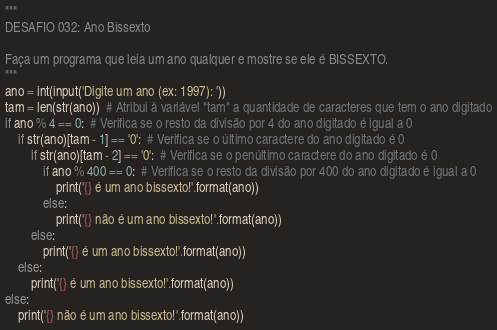<code> <loc_0><loc_0><loc_500><loc_500><_Python_>"""
DESAFIO 032: Ano Bissexto

Faça um programa que leia um ano qualquer e mostre se ele é BISSEXTO.
"""
ano = int(input('Digite um ano (ex: 1997): '))
tam = len(str(ano))  # Atribui à variável "tam" a quantidade de caracteres que tem o ano digitado
if ano % 4 == 0:  # Verifica se o resto da divisão por 4 do ano digitado é igual a 0
    if str(ano)[tam - 1] == '0':  # Verifica se o último caractere do ano digitado é 0
        if str(ano)[tam - 2] == '0':  # Verifica se o penúltimo caractere do ano digitado é 0
            if ano % 400 == 0:  # Verifica se o resto da divisão por 400 do ano digitado é igual a 0
                print('{} é um ano bissexto!'.format(ano))
            else:
                print('{} não é um ano bissexto!'.format(ano))
        else:
            print('{} é um ano bissexto!'.format(ano))
    else:
        print('{} é um ano bissexto!'.format(ano))
else:
    print('{} não é um ano bissexto!'.format(ano))
</code> 